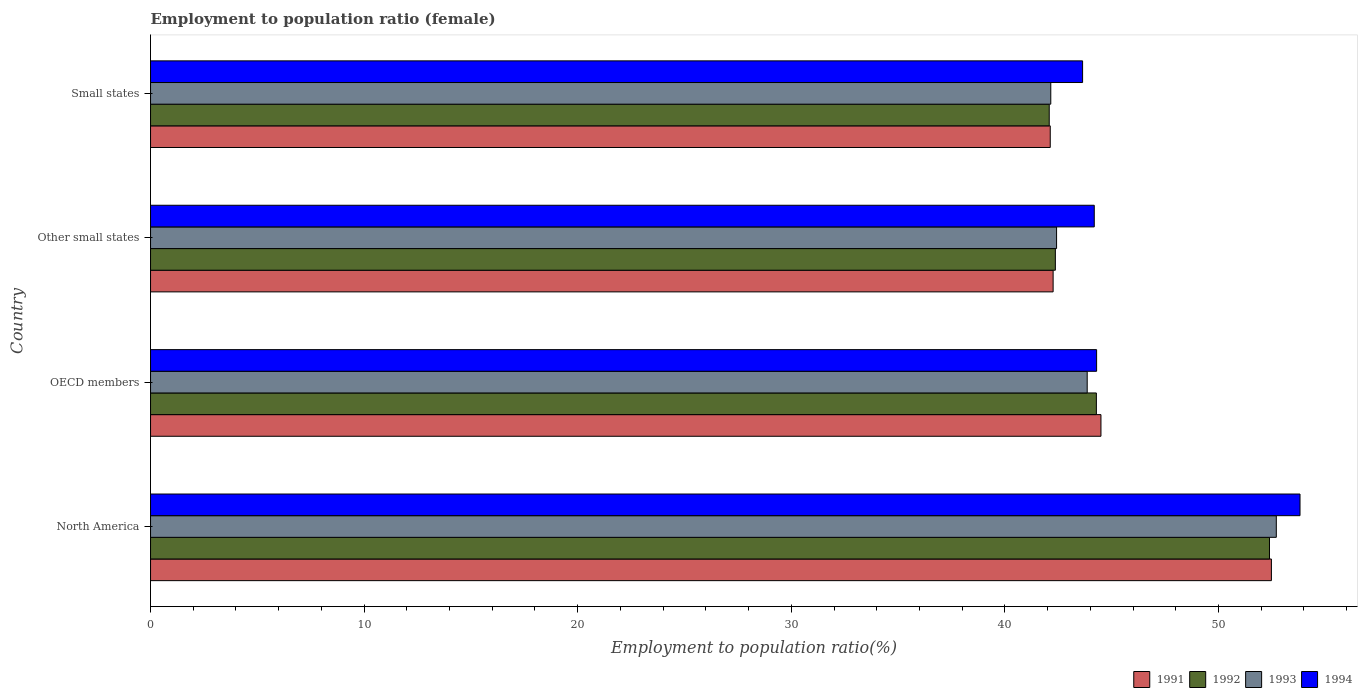Are the number of bars on each tick of the Y-axis equal?
Offer a terse response. Yes. How many bars are there on the 1st tick from the bottom?
Your answer should be compact. 4. What is the label of the 2nd group of bars from the top?
Keep it short and to the point. Other small states. In how many cases, is the number of bars for a given country not equal to the number of legend labels?
Make the answer very short. 0. What is the employment to population ratio in 1993 in Other small states?
Your answer should be very brief. 42.42. Across all countries, what is the maximum employment to population ratio in 1991?
Keep it short and to the point. 52.48. Across all countries, what is the minimum employment to population ratio in 1994?
Provide a short and direct response. 43.64. In which country was the employment to population ratio in 1994 maximum?
Your response must be concise. North America. In which country was the employment to population ratio in 1991 minimum?
Provide a short and direct response. Small states. What is the total employment to population ratio in 1992 in the graph?
Ensure brevity in your answer.  181.12. What is the difference between the employment to population ratio in 1993 in OECD members and that in Other small states?
Give a very brief answer. 1.43. What is the difference between the employment to population ratio in 1993 in Other small states and the employment to population ratio in 1991 in North America?
Your answer should be very brief. -10.06. What is the average employment to population ratio in 1992 per country?
Ensure brevity in your answer.  45.28. What is the difference between the employment to population ratio in 1994 and employment to population ratio in 1992 in Small states?
Your answer should be very brief. 1.56. In how many countries, is the employment to population ratio in 1994 greater than 2 %?
Keep it short and to the point. 4. What is the ratio of the employment to population ratio in 1993 in OECD members to that in Other small states?
Your response must be concise. 1.03. Is the employment to population ratio in 1994 in North America less than that in Small states?
Keep it short and to the point. No. What is the difference between the highest and the second highest employment to population ratio in 1993?
Give a very brief answer. 8.85. What is the difference between the highest and the lowest employment to population ratio in 1994?
Offer a terse response. 10.18. In how many countries, is the employment to population ratio in 1992 greater than the average employment to population ratio in 1992 taken over all countries?
Your response must be concise. 1. Is it the case that in every country, the sum of the employment to population ratio in 1994 and employment to population ratio in 1992 is greater than the sum of employment to population ratio in 1991 and employment to population ratio in 1993?
Give a very brief answer. No. What does the 2nd bar from the top in Other small states represents?
Ensure brevity in your answer.  1993. Is it the case that in every country, the sum of the employment to population ratio in 1994 and employment to population ratio in 1991 is greater than the employment to population ratio in 1992?
Provide a short and direct response. Yes. What is the difference between two consecutive major ticks on the X-axis?
Your response must be concise. 10. Are the values on the major ticks of X-axis written in scientific E-notation?
Provide a succinct answer. No. Does the graph contain any zero values?
Your answer should be very brief. No. Where does the legend appear in the graph?
Give a very brief answer. Bottom right. How are the legend labels stacked?
Give a very brief answer. Horizontal. What is the title of the graph?
Provide a short and direct response. Employment to population ratio (female). Does "1967" appear as one of the legend labels in the graph?
Your answer should be compact. No. What is the label or title of the X-axis?
Provide a short and direct response. Employment to population ratio(%). What is the label or title of the Y-axis?
Your answer should be compact. Country. What is the Employment to population ratio(%) of 1991 in North America?
Make the answer very short. 52.48. What is the Employment to population ratio(%) in 1992 in North America?
Give a very brief answer. 52.39. What is the Employment to population ratio(%) of 1993 in North America?
Offer a very short reply. 52.71. What is the Employment to population ratio(%) of 1994 in North America?
Keep it short and to the point. 53.82. What is the Employment to population ratio(%) in 1991 in OECD members?
Your answer should be compact. 44.5. What is the Employment to population ratio(%) of 1992 in OECD members?
Provide a succinct answer. 44.28. What is the Employment to population ratio(%) in 1993 in OECD members?
Your response must be concise. 43.86. What is the Employment to population ratio(%) of 1994 in OECD members?
Your answer should be very brief. 44.3. What is the Employment to population ratio(%) of 1991 in Other small states?
Offer a terse response. 42.26. What is the Employment to population ratio(%) of 1992 in Other small states?
Keep it short and to the point. 42.36. What is the Employment to population ratio(%) of 1993 in Other small states?
Your answer should be compact. 42.42. What is the Employment to population ratio(%) of 1994 in Other small states?
Your answer should be very brief. 44.19. What is the Employment to population ratio(%) in 1991 in Small states?
Make the answer very short. 42.13. What is the Employment to population ratio(%) in 1992 in Small states?
Provide a short and direct response. 42.08. What is the Employment to population ratio(%) of 1993 in Small states?
Give a very brief answer. 42.15. What is the Employment to population ratio(%) of 1994 in Small states?
Keep it short and to the point. 43.64. Across all countries, what is the maximum Employment to population ratio(%) in 1991?
Your response must be concise. 52.48. Across all countries, what is the maximum Employment to population ratio(%) in 1992?
Provide a succinct answer. 52.39. Across all countries, what is the maximum Employment to population ratio(%) of 1993?
Your answer should be very brief. 52.71. Across all countries, what is the maximum Employment to population ratio(%) of 1994?
Your answer should be compact. 53.82. Across all countries, what is the minimum Employment to population ratio(%) of 1991?
Your response must be concise. 42.13. Across all countries, what is the minimum Employment to population ratio(%) in 1992?
Provide a short and direct response. 42.08. Across all countries, what is the minimum Employment to population ratio(%) in 1993?
Offer a terse response. 42.15. Across all countries, what is the minimum Employment to population ratio(%) in 1994?
Provide a short and direct response. 43.64. What is the total Employment to population ratio(%) of 1991 in the graph?
Provide a succinct answer. 181.36. What is the total Employment to population ratio(%) in 1992 in the graph?
Your response must be concise. 181.12. What is the total Employment to population ratio(%) of 1993 in the graph?
Make the answer very short. 181.14. What is the total Employment to population ratio(%) in 1994 in the graph?
Keep it short and to the point. 185.94. What is the difference between the Employment to population ratio(%) in 1991 in North America and that in OECD members?
Give a very brief answer. 7.98. What is the difference between the Employment to population ratio(%) in 1992 in North America and that in OECD members?
Your response must be concise. 8.1. What is the difference between the Employment to population ratio(%) in 1993 in North America and that in OECD members?
Offer a very short reply. 8.85. What is the difference between the Employment to population ratio(%) in 1994 in North America and that in OECD members?
Your response must be concise. 9.52. What is the difference between the Employment to population ratio(%) in 1991 in North America and that in Other small states?
Your answer should be compact. 10.22. What is the difference between the Employment to population ratio(%) of 1992 in North America and that in Other small states?
Your answer should be very brief. 10.03. What is the difference between the Employment to population ratio(%) in 1993 in North America and that in Other small states?
Provide a succinct answer. 10.29. What is the difference between the Employment to population ratio(%) in 1994 in North America and that in Other small states?
Your response must be concise. 9.63. What is the difference between the Employment to population ratio(%) of 1991 in North America and that in Small states?
Your answer should be compact. 10.35. What is the difference between the Employment to population ratio(%) of 1992 in North America and that in Small states?
Ensure brevity in your answer.  10.31. What is the difference between the Employment to population ratio(%) in 1993 in North America and that in Small states?
Ensure brevity in your answer.  10.56. What is the difference between the Employment to population ratio(%) of 1994 in North America and that in Small states?
Provide a short and direct response. 10.18. What is the difference between the Employment to population ratio(%) of 1991 in OECD members and that in Other small states?
Your answer should be very brief. 2.24. What is the difference between the Employment to population ratio(%) of 1992 in OECD members and that in Other small states?
Your answer should be very brief. 1.92. What is the difference between the Employment to population ratio(%) in 1993 in OECD members and that in Other small states?
Your answer should be very brief. 1.43. What is the difference between the Employment to population ratio(%) of 1994 in OECD members and that in Other small states?
Make the answer very short. 0.11. What is the difference between the Employment to population ratio(%) in 1991 in OECD members and that in Small states?
Offer a terse response. 2.37. What is the difference between the Employment to population ratio(%) of 1992 in OECD members and that in Small states?
Ensure brevity in your answer.  2.21. What is the difference between the Employment to population ratio(%) of 1993 in OECD members and that in Small states?
Provide a short and direct response. 1.71. What is the difference between the Employment to population ratio(%) of 1994 in OECD members and that in Small states?
Provide a short and direct response. 0.66. What is the difference between the Employment to population ratio(%) of 1991 in Other small states and that in Small states?
Your answer should be compact. 0.13. What is the difference between the Employment to population ratio(%) of 1992 in Other small states and that in Small states?
Make the answer very short. 0.29. What is the difference between the Employment to population ratio(%) of 1993 in Other small states and that in Small states?
Your response must be concise. 0.27. What is the difference between the Employment to population ratio(%) in 1994 in Other small states and that in Small states?
Give a very brief answer. 0.55. What is the difference between the Employment to population ratio(%) in 1991 in North America and the Employment to population ratio(%) in 1992 in OECD members?
Offer a terse response. 8.2. What is the difference between the Employment to population ratio(%) of 1991 in North America and the Employment to population ratio(%) of 1993 in OECD members?
Your answer should be compact. 8.62. What is the difference between the Employment to population ratio(%) in 1991 in North America and the Employment to population ratio(%) in 1994 in OECD members?
Offer a terse response. 8.18. What is the difference between the Employment to population ratio(%) of 1992 in North America and the Employment to population ratio(%) of 1993 in OECD members?
Give a very brief answer. 8.53. What is the difference between the Employment to population ratio(%) of 1992 in North America and the Employment to population ratio(%) of 1994 in OECD members?
Offer a terse response. 8.09. What is the difference between the Employment to population ratio(%) of 1993 in North America and the Employment to population ratio(%) of 1994 in OECD members?
Provide a short and direct response. 8.41. What is the difference between the Employment to population ratio(%) in 1991 in North America and the Employment to population ratio(%) in 1992 in Other small states?
Ensure brevity in your answer.  10.12. What is the difference between the Employment to population ratio(%) in 1991 in North America and the Employment to population ratio(%) in 1993 in Other small states?
Keep it short and to the point. 10.06. What is the difference between the Employment to population ratio(%) in 1991 in North America and the Employment to population ratio(%) in 1994 in Other small states?
Offer a terse response. 8.29. What is the difference between the Employment to population ratio(%) in 1992 in North America and the Employment to population ratio(%) in 1993 in Other small states?
Make the answer very short. 9.97. What is the difference between the Employment to population ratio(%) of 1992 in North America and the Employment to population ratio(%) of 1994 in Other small states?
Keep it short and to the point. 8.2. What is the difference between the Employment to population ratio(%) in 1993 in North America and the Employment to population ratio(%) in 1994 in Other small states?
Offer a very short reply. 8.52. What is the difference between the Employment to population ratio(%) in 1991 in North America and the Employment to population ratio(%) in 1992 in Small states?
Give a very brief answer. 10.4. What is the difference between the Employment to population ratio(%) in 1991 in North America and the Employment to population ratio(%) in 1993 in Small states?
Give a very brief answer. 10.33. What is the difference between the Employment to population ratio(%) in 1991 in North America and the Employment to population ratio(%) in 1994 in Small states?
Ensure brevity in your answer.  8.84. What is the difference between the Employment to population ratio(%) of 1992 in North America and the Employment to population ratio(%) of 1993 in Small states?
Offer a very short reply. 10.24. What is the difference between the Employment to population ratio(%) in 1992 in North America and the Employment to population ratio(%) in 1994 in Small states?
Give a very brief answer. 8.75. What is the difference between the Employment to population ratio(%) in 1993 in North America and the Employment to population ratio(%) in 1994 in Small states?
Make the answer very short. 9.07. What is the difference between the Employment to population ratio(%) of 1991 in OECD members and the Employment to population ratio(%) of 1992 in Other small states?
Offer a very short reply. 2.14. What is the difference between the Employment to population ratio(%) of 1991 in OECD members and the Employment to population ratio(%) of 1993 in Other small states?
Offer a terse response. 2.08. What is the difference between the Employment to population ratio(%) in 1991 in OECD members and the Employment to population ratio(%) in 1994 in Other small states?
Provide a short and direct response. 0.31. What is the difference between the Employment to population ratio(%) of 1992 in OECD members and the Employment to population ratio(%) of 1993 in Other small states?
Your response must be concise. 1.86. What is the difference between the Employment to population ratio(%) of 1992 in OECD members and the Employment to population ratio(%) of 1994 in Other small states?
Your answer should be very brief. 0.1. What is the difference between the Employment to population ratio(%) in 1993 in OECD members and the Employment to population ratio(%) in 1994 in Other small states?
Your answer should be compact. -0.33. What is the difference between the Employment to population ratio(%) of 1991 in OECD members and the Employment to population ratio(%) of 1992 in Small states?
Your response must be concise. 2.42. What is the difference between the Employment to population ratio(%) of 1991 in OECD members and the Employment to population ratio(%) of 1993 in Small states?
Your answer should be compact. 2.35. What is the difference between the Employment to population ratio(%) in 1991 in OECD members and the Employment to population ratio(%) in 1994 in Small states?
Ensure brevity in your answer.  0.86. What is the difference between the Employment to population ratio(%) of 1992 in OECD members and the Employment to population ratio(%) of 1993 in Small states?
Your answer should be compact. 2.13. What is the difference between the Employment to population ratio(%) of 1992 in OECD members and the Employment to population ratio(%) of 1994 in Small states?
Keep it short and to the point. 0.65. What is the difference between the Employment to population ratio(%) of 1993 in OECD members and the Employment to population ratio(%) of 1994 in Small states?
Offer a very short reply. 0.22. What is the difference between the Employment to population ratio(%) of 1991 in Other small states and the Employment to population ratio(%) of 1992 in Small states?
Provide a succinct answer. 0.18. What is the difference between the Employment to population ratio(%) in 1991 in Other small states and the Employment to population ratio(%) in 1993 in Small states?
Keep it short and to the point. 0.11. What is the difference between the Employment to population ratio(%) in 1991 in Other small states and the Employment to population ratio(%) in 1994 in Small states?
Offer a terse response. -1.38. What is the difference between the Employment to population ratio(%) of 1992 in Other small states and the Employment to population ratio(%) of 1993 in Small states?
Provide a short and direct response. 0.21. What is the difference between the Employment to population ratio(%) in 1992 in Other small states and the Employment to population ratio(%) in 1994 in Small states?
Your response must be concise. -1.28. What is the difference between the Employment to population ratio(%) in 1993 in Other small states and the Employment to population ratio(%) in 1994 in Small states?
Ensure brevity in your answer.  -1.22. What is the average Employment to population ratio(%) in 1991 per country?
Provide a short and direct response. 45.34. What is the average Employment to population ratio(%) in 1992 per country?
Ensure brevity in your answer.  45.28. What is the average Employment to population ratio(%) of 1993 per country?
Your answer should be very brief. 45.28. What is the average Employment to population ratio(%) of 1994 per country?
Keep it short and to the point. 46.48. What is the difference between the Employment to population ratio(%) of 1991 and Employment to population ratio(%) of 1992 in North America?
Your answer should be compact. 0.09. What is the difference between the Employment to population ratio(%) in 1991 and Employment to population ratio(%) in 1993 in North America?
Offer a terse response. -0.23. What is the difference between the Employment to population ratio(%) of 1991 and Employment to population ratio(%) of 1994 in North America?
Offer a very short reply. -1.34. What is the difference between the Employment to population ratio(%) in 1992 and Employment to population ratio(%) in 1993 in North America?
Ensure brevity in your answer.  -0.32. What is the difference between the Employment to population ratio(%) of 1992 and Employment to population ratio(%) of 1994 in North America?
Provide a short and direct response. -1.43. What is the difference between the Employment to population ratio(%) in 1993 and Employment to population ratio(%) in 1994 in North America?
Your answer should be compact. -1.11. What is the difference between the Employment to population ratio(%) in 1991 and Employment to population ratio(%) in 1992 in OECD members?
Offer a very short reply. 0.21. What is the difference between the Employment to population ratio(%) of 1991 and Employment to population ratio(%) of 1993 in OECD members?
Make the answer very short. 0.64. What is the difference between the Employment to population ratio(%) in 1991 and Employment to population ratio(%) in 1994 in OECD members?
Your answer should be compact. 0.2. What is the difference between the Employment to population ratio(%) in 1992 and Employment to population ratio(%) in 1993 in OECD members?
Offer a terse response. 0.43. What is the difference between the Employment to population ratio(%) of 1992 and Employment to population ratio(%) of 1994 in OECD members?
Provide a short and direct response. -0.01. What is the difference between the Employment to population ratio(%) in 1993 and Employment to population ratio(%) in 1994 in OECD members?
Make the answer very short. -0.44. What is the difference between the Employment to population ratio(%) in 1991 and Employment to population ratio(%) in 1992 in Other small states?
Your response must be concise. -0.1. What is the difference between the Employment to population ratio(%) of 1991 and Employment to population ratio(%) of 1993 in Other small states?
Keep it short and to the point. -0.16. What is the difference between the Employment to population ratio(%) in 1991 and Employment to population ratio(%) in 1994 in Other small states?
Your answer should be compact. -1.93. What is the difference between the Employment to population ratio(%) of 1992 and Employment to population ratio(%) of 1993 in Other small states?
Ensure brevity in your answer.  -0.06. What is the difference between the Employment to population ratio(%) in 1992 and Employment to population ratio(%) in 1994 in Other small states?
Provide a succinct answer. -1.82. What is the difference between the Employment to population ratio(%) in 1993 and Employment to population ratio(%) in 1994 in Other small states?
Make the answer very short. -1.76. What is the difference between the Employment to population ratio(%) of 1991 and Employment to population ratio(%) of 1992 in Small states?
Keep it short and to the point. 0.05. What is the difference between the Employment to population ratio(%) of 1991 and Employment to population ratio(%) of 1993 in Small states?
Your answer should be compact. -0.02. What is the difference between the Employment to population ratio(%) in 1991 and Employment to population ratio(%) in 1994 in Small states?
Offer a terse response. -1.51. What is the difference between the Employment to population ratio(%) of 1992 and Employment to population ratio(%) of 1993 in Small states?
Keep it short and to the point. -0.07. What is the difference between the Employment to population ratio(%) in 1992 and Employment to population ratio(%) in 1994 in Small states?
Your answer should be very brief. -1.56. What is the difference between the Employment to population ratio(%) of 1993 and Employment to population ratio(%) of 1994 in Small states?
Ensure brevity in your answer.  -1.49. What is the ratio of the Employment to population ratio(%) in 1991 in North America to that in OECD members?
Make the answer very short. 1.18. What is the ratio of the Employment to population ratio(%) of 1992 in North America to that in OECD members?
Offer a terse response. 1.18. What is the ratio of the Employment to population ratio(%) in 1993 in North America to that in OECD members?
Provide a succinct answer. 1.2. What is the ratio of the Employment to population ratio(%) in 1994 in North America to that in OECD members?
Give a very brief answer. 1.22. What is the ratio of the Employment to population ratio(%) in 1991 in North America to that in Other small states?
Keep it short and to the point. 1.24. What is the ratio of the Employment to population ratio(%) in 1992 in North America to that in Other small states?
Provide a short and direct response. 1.24. What is the ratio of the Employment to population ratio(%) of 1993 in North America to that in Other small states?
Offer a very short reply. 1.24. What is the ratio of the Employment to population ratio(%) in 1994 in North America to that in Other small states?
Offer a terse response. 1.22. What is the ratio of the Employment to population ratio(%) of 1991 in North America to that in Small states?
Your answer should be compact. 1.25. What is the ratio of the Employment to population ratio(%) of 1992 in North America to that in Small states?
Make the answer very short. 1.25. What is the ratio of the Employment to population ratio(%) of 1993 in North America to that in Small states?
Offer a terse response. 1.25. What is the ratio of the Employment to population ratio(%) in 1994 in North America to that in Small states?
Ensure brevity in your answer.  1.23. What is the ratio of the Employment to population ratio(%) in 1991 in OECD members to that in Other small states?
Your answer should be compact. 1.05. What is the ratio of the Employment to population ratio(%) in 1992 in OECD members to that in Other small states?
Keep it short and to the point. 1.05. What is the ratio of the Employment to population ratio(%) of 1993 in OECD members to that in Other small states?
Offer a terse response. 1.03. What is the ratio of the Employment to population ratio(%) in 1991 in OECD members to that in Small states?
Make the answer very short. 1.06. What is the ratio of the Employment to population ratio(%) in 1992 in OECD members to that in Small states?
Keep it short and to the point. 1.05. What is the ratio of the Employment to population ratio(%) of 1993 in OECD members to that in Small states?
Your answer should be very brief. 1.04. What is the ratio of the Employment to population ratio(%) in 1991 in Other small states to that in Small states?
Ensure brevity in your answer.  1. What is the ratio of the Employment to population ratio(%) of 1992 in Other small states to that in Small states?
Offer a very short reply. 1.01. What is the ratio of the Employment to population ratio(%) in 1993 in Other small states to that in Small states?
Give a very brief answer. 1.01. What is the ratio of the Employment to population ratio(%) of 1994 in Other small states to that in Small states?
Your answer should be very brief. 1.01. What is the difference between the highest and the second highest Employment to population ratio(%) in 1991?
Give a very brief answer. 7.98. What is the difference between the highest and the second highest Employment to population ratio(%) in 1992?
Your answer should be very brief. 8.1. What is the difference between the highest and the second highest Employment to population ratio(%) of 1993?
Ensure brevity in your answer.  8.85. What is the difference between the highest and the second highest Employment to population ratio(%) of 1994?
Offer a very short reply. 9.52. What is the difference between the highest and the lowest Employment to population ratio(%) in 1991?
Keep it short and to the point. 10.35. What is the difference between the highest and the lowest Employment to population ratio(%) of 1992?
Give a very brief answer. 10.31. What is the difference between the highest and the lowest Employment to population ratio(%) of 1993?
Provide a short and direct response. 10.56. What is the difference between the highest and the lowest Employment to population ratio(%) of 1994?
Keep it short and to the point. 10.18. 